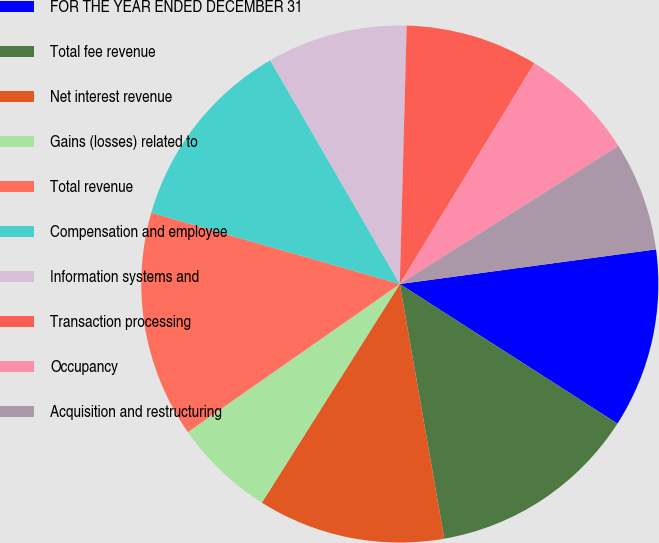Convert chart. <chart><loc_0><loc_0><loc_500><loc_500><pie_chart><fcel>FOR THE YEAR ENDED DECEMBER 31<fcel>Total fee revenue<fcel>Net interest revenue<fcel>Gains (losses) related to<fcel>Total revenue<fcel>Compensation and employee<fcel>Information systems and<fcel>Transaction processing<fcel>Occupancy<fcel>Acquisition and restructuring<nl><fcel>11.22%<fcel>13.17%<fcel>11.71%<fcel>6.34%<fcel>14.15%<fcel>12.2%<fcel>8.78%<fcel>8.29%<fcel>7.32%<fcel>6.83%<nl></chart> 